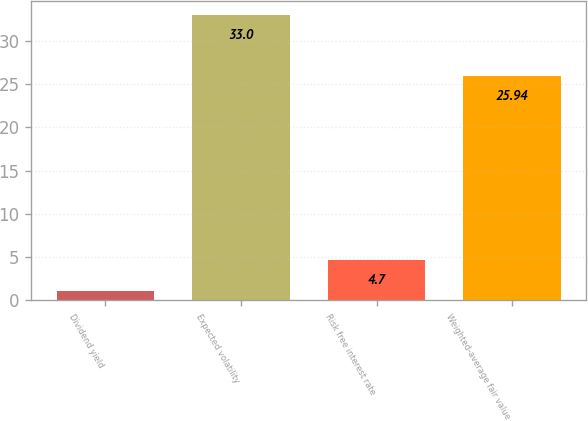Convert chart to OTSL. <chart><loc_0><loc_0><loc_500><loc_500><bar_chart><fcel>Dividend yield<fcel>Expected volatility<fcel>Risk free interest rate<fcel>Weighted-average fair value<nl><fcel>1.1<fcel>33<fcel>4.7<fcel>25.94<nl></chart> 